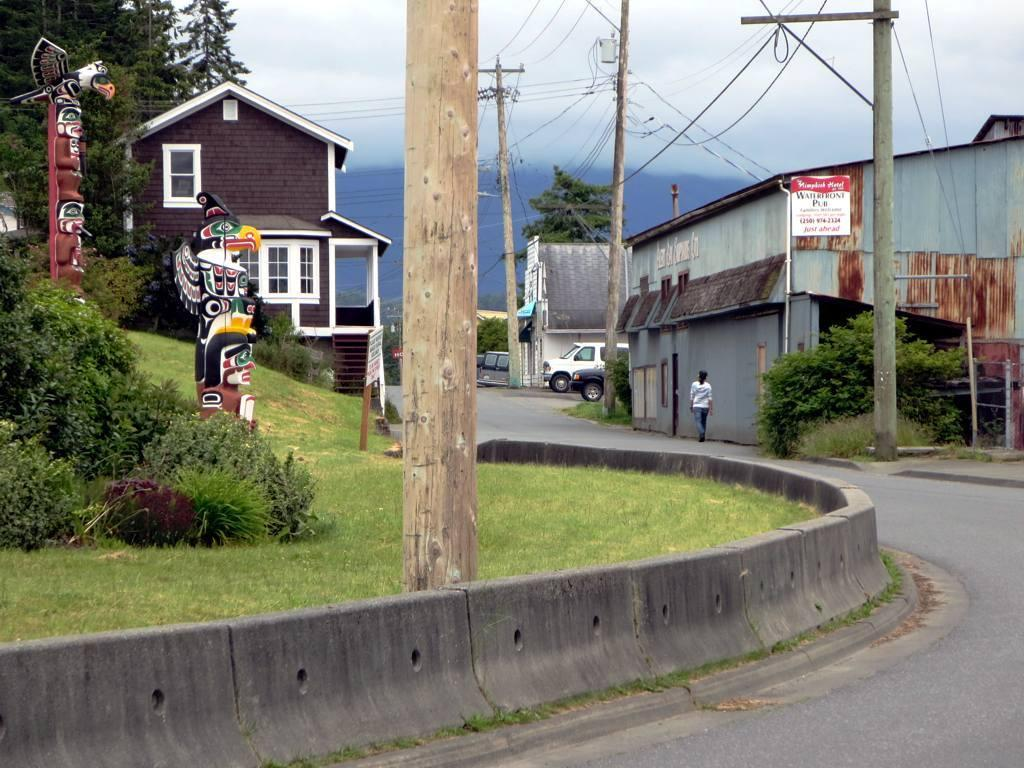What is present in the image? There is a person, buildings, statues, current poles, a hill, and the sky is visible in the image. Can you describe the person in the image? The provided facts do not give a detailed description of the person. What type of structures can be seen in the image? There are buildings and statues visible in the image. What is the weather like in the image? The sky is visible in the image, and there are clouds visible, which suggests a partly cloudy day. Can you tell me how many firemen are depicted in the image? There is no fireman present in the image. What type of root can be seen growing on the hill in the image? There is no root visible in the image; it features a hill and other elements but no roots. What is the intensity of the rainstorm in the image? There is no rainstorm present in the image; it features a hill, buildings, and other elements but no rainstorm. 